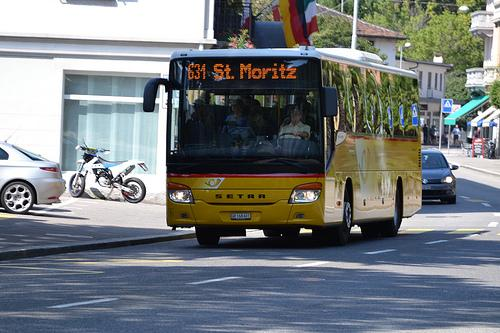Mention any notable car color and brand from the scene depicted. There is a grey Volkswagen car in the image. What is the person sitting in the central object wearing and what are they doing? A man in a yellow shirt is driving the bus. Comment on the vehicle situated immediately behind the bus. There is a car driving behind the yellow bus. Describe the appearance of the bus's logo. The logo on the bus says "Setra." In the image, what are two other vehicles besides the main subject? There are a grey Volkswagen car and a parked motorcycle. Describe the activity of the passengers inside the main object. The passengers are sitting inside the bus. State the primary subject of the image and its destination according to its sign. The yellow bus is driving towards 631 St Moritz. Identify one significant detail about the bus's appearance. The bus has a destination sign reading "631 St Moritz." What is a noticeable feature of the motorcycle parked by the building? The motorcycle has a silver kickstand. Mention the central object in the picture and its color. There is a yellow bus on the road in the image. 